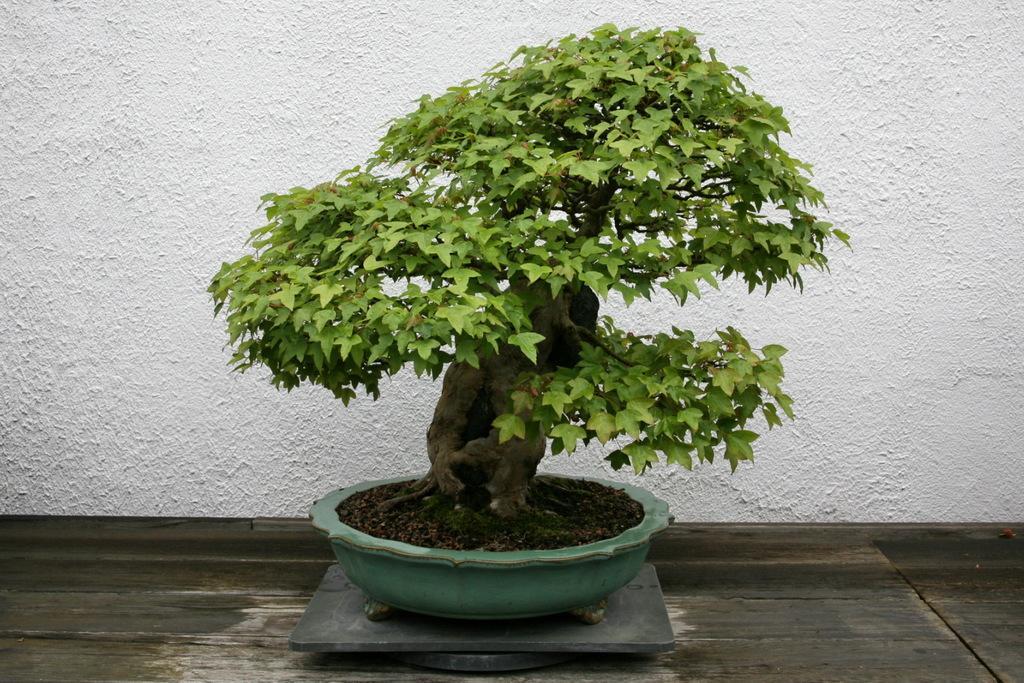Please provide a concise description of this image. As we can see in the image there is a white color wall, bonsai and pot. 